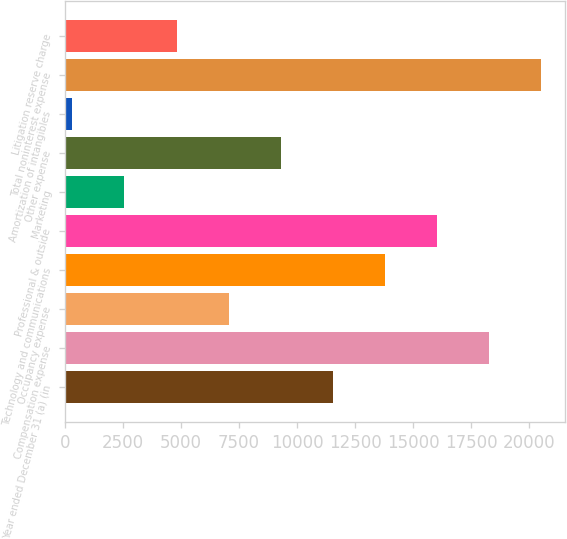<chart> <loc_0><loc_0><loc_500><loc_500><bar_chart><fcel>Year ended December 31 (a) (in<fcel>Compensation expense<fcel>Occupancy expense<fcel>Technology and communications<fcel>Professional & outside<fcel>Marketing<fcel>Other expense<fcel>Amortization of intangibles<fcel>Total noninterest expense<fcel>Litigation reserve charge<nl><fcel>11543.5<fcel>18275.8<fcel>7055.3<fcel>13787.6<fcel>16031.7<fcel>2567.1<fcel>9299.4<fcel>323<fcel>20519.9<fcel>4811.2<nl></chart> 